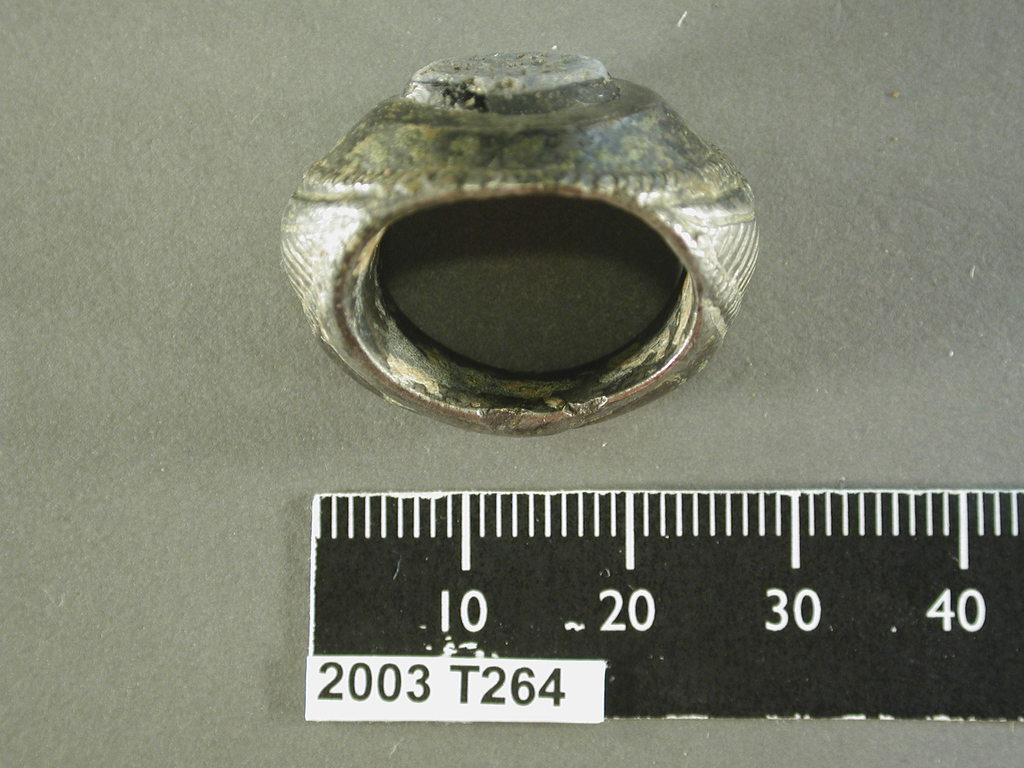Provide a one-sentence caption for the provided image. An old ring sits next to a ruler that says 2003 T264. 